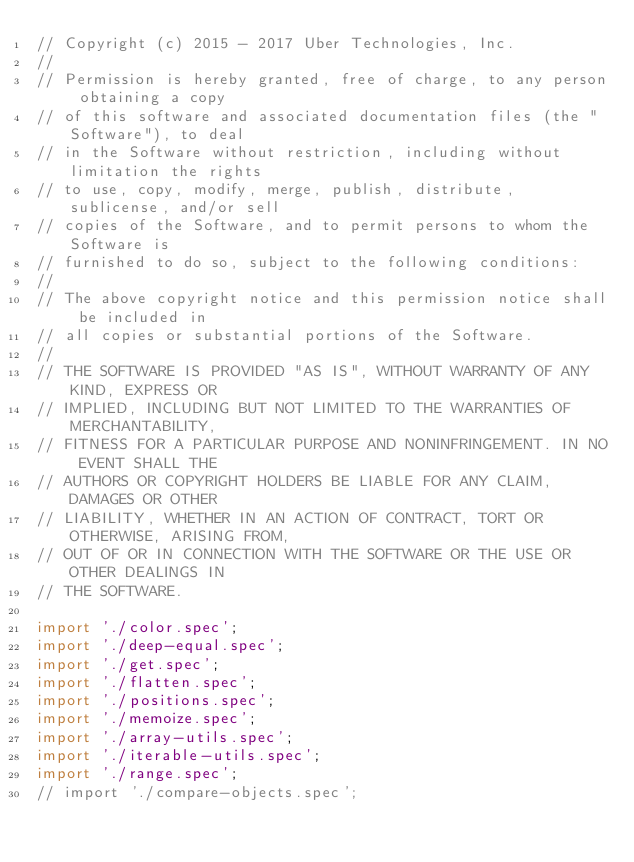Convert code to text. <code><loc_0><loc_0><loc_500><loc_500><_JavaScript_>// Copyright (c) 2015 - 2017 Uber Technologies, Inc.
//
// Permission is hereby granted, free of charge, to any person obtaining a copy
// of this software and associated documentation files (the "Software"), to deal
// in the Software without restriction, including without limitation the rights
// to use, copy, modify, merge, publish, distribute, sublicense, and/or sell
// copies of the Software, and to permit persons to whom the Software is
// furnished to do so, subject to the following conditions:
//
// The above copyright notice and this permission notice shall be included in
// all copies or substantial portions of the Software.
//
// THE SOFTWARE IS PROVIDED "AS IS", WITHOUT WARRANTY OF ANY KIND, EXPRESS OR
// IMPLIED, INCLUDING BUT NOT LIMITED TO THE WARRANTIES OF MERCHANTABILITY,
// FITNESS FOR A PARTICULAR PURPOSE AND NONINFRINGEMENT. IN NO EVENT SHALL THE
// AUTHORS OR COPYRIGHT HOLDERS BE LIABLE FOR ANY CLAIM, DAMAGES OR OTHER
// LIABILITY, WHETHER IN AN ACTION OF CONTRACT, TORT OR OTHERWISE, ARISING FROM,
// OUT OF OR IN CONNECTION WITH THE SOFTWARE OR THE USE OR OTHER DEALINGS IN
// THE SOFTWARE.

import './color.spec';
import './deep-equal.spec';
import './get.spec';
import './flatten.spec';
import './positions.spec';
import './memoize.spec';
import './array-utils.spec';
import './iterable-utils.spec';
import './range.spec';
// import './compare-objects.spec';
</code> 